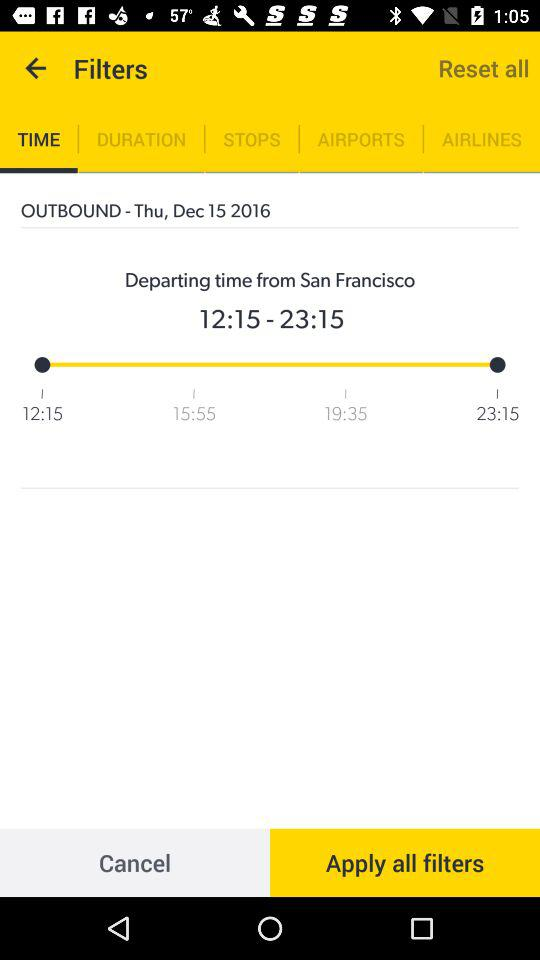Which tab is currently selected under filters? The selected tab is "TIME". 